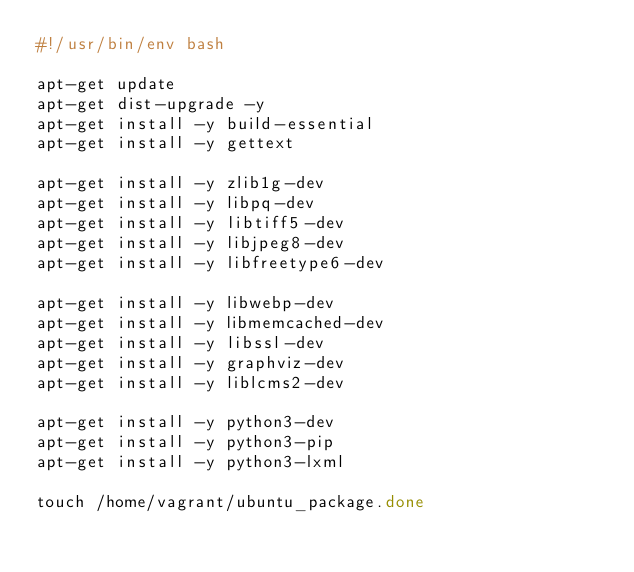Convert code to text. <code><loc_0><loc_0><loc_500><loc_500><_Bash_>#!/usr/bin/env bash

apt-get update
apt-get dist-upgrade -y
apt-get install -y build-essential
apt-get install -y gettext

apt-get install -y zlib1g-dev
apt-get install -y libpq-dev
apt-get install -y libtiff5-dev
apt-get install -y libjpeg8-dev
apt-get install -y libfreetype6-dev

apt-get install -y libwebp-dev
apt-get install -y libmemcached-dev
apt-get install -y libssl-dev
apt-get install -y graphviz-dev
apt-get install -y liblcms2-dev

apt-get install -y python3-dev
apt-get install -y python3-pip
apt-get install -y python3-lxml

touch /home/vagrant/ubuntu_package.done
</code> 